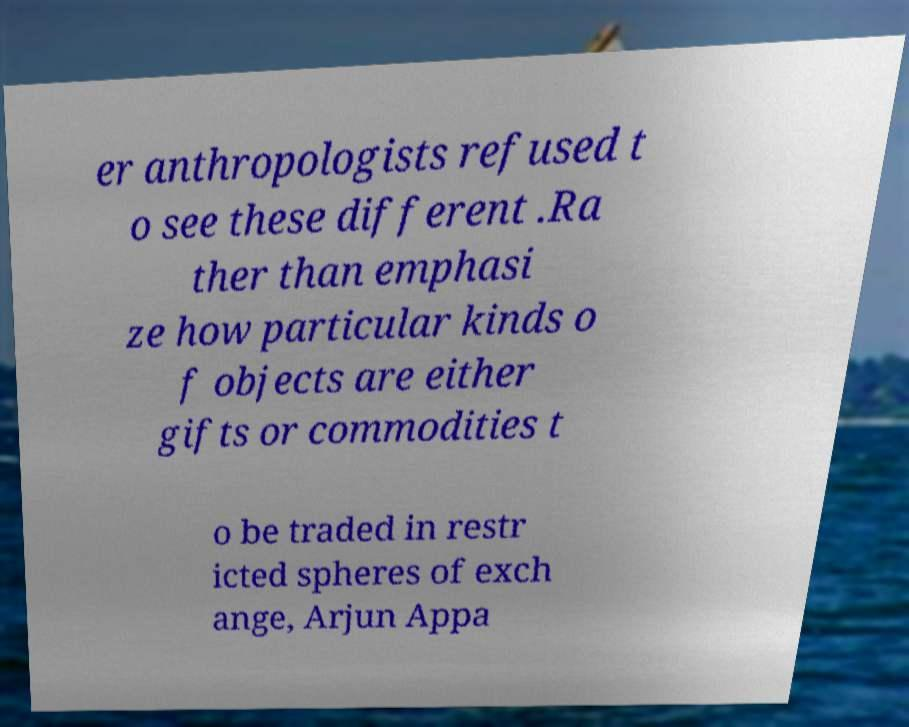Could you extract and type out the text from this image? er anthropologists refused t o see these different .Ra ther than emphasi ze how particular kinds o f objects are either gifts or commodities t o be traded in restr icted spheres of exch ange, Arjun Appa 